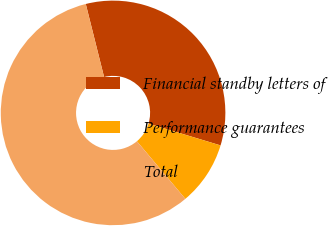Convert chart. <chart><loc_0><loc_0><loc_500><loc_500><pie_chart><fcel>Financial standby letters of<fcel>Performance guarantees<fcel>Total<nl><fcel>33.58%<fcel>9.2%<fcel>57.21%<nl></chart> 